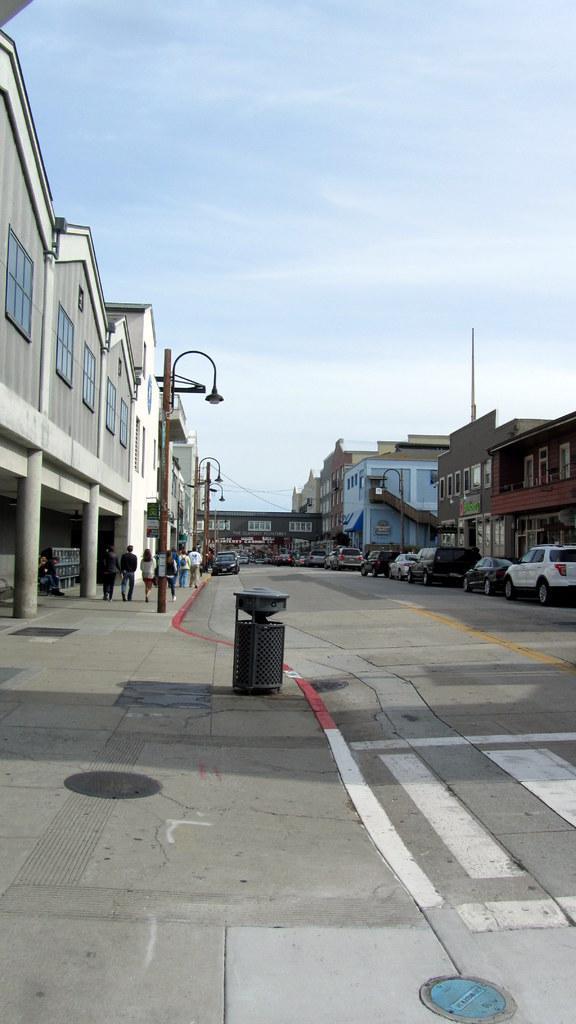In one or two sentences, can you explain what this image depicts? This picture is taken outside and in the foreground of this image, there is a road to which buildings, poles, and vehicles are on either sides of the road. On top, we see the sky. 